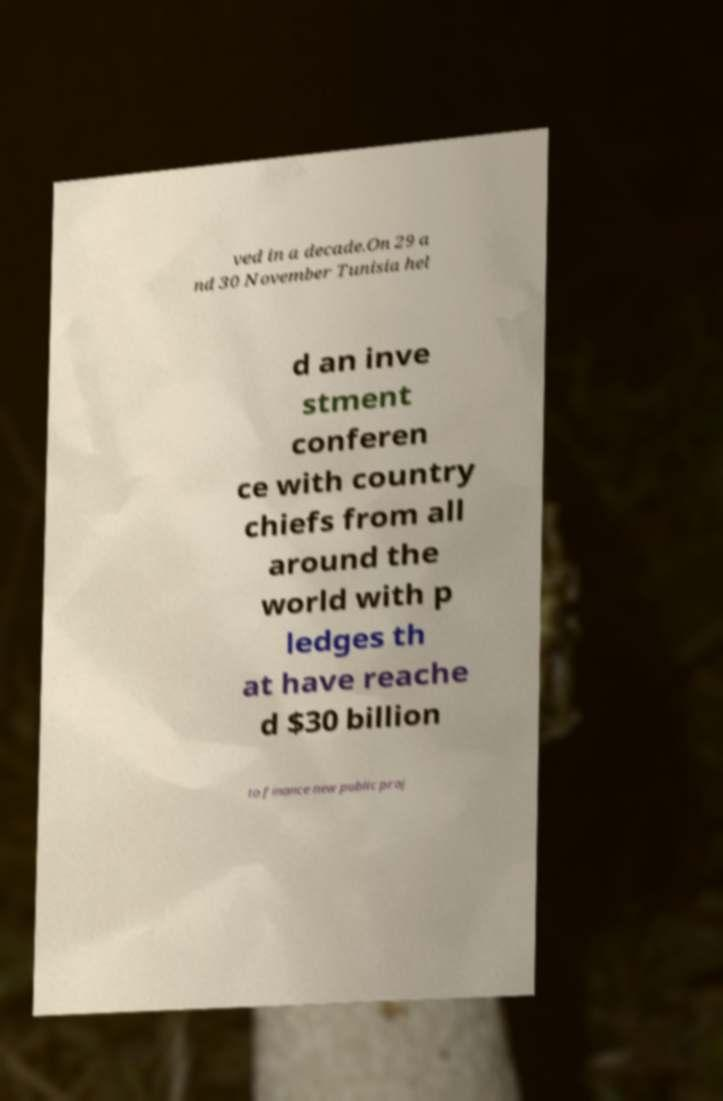Can you accurately transcribe the text from the provided image for me? ved in a decade.On 29 a nd 30 November Tunisia hel d an inve stment conferen ce with country chiefs from all around the world with p ledges th at have reache d $30 billion to finance new public proj 